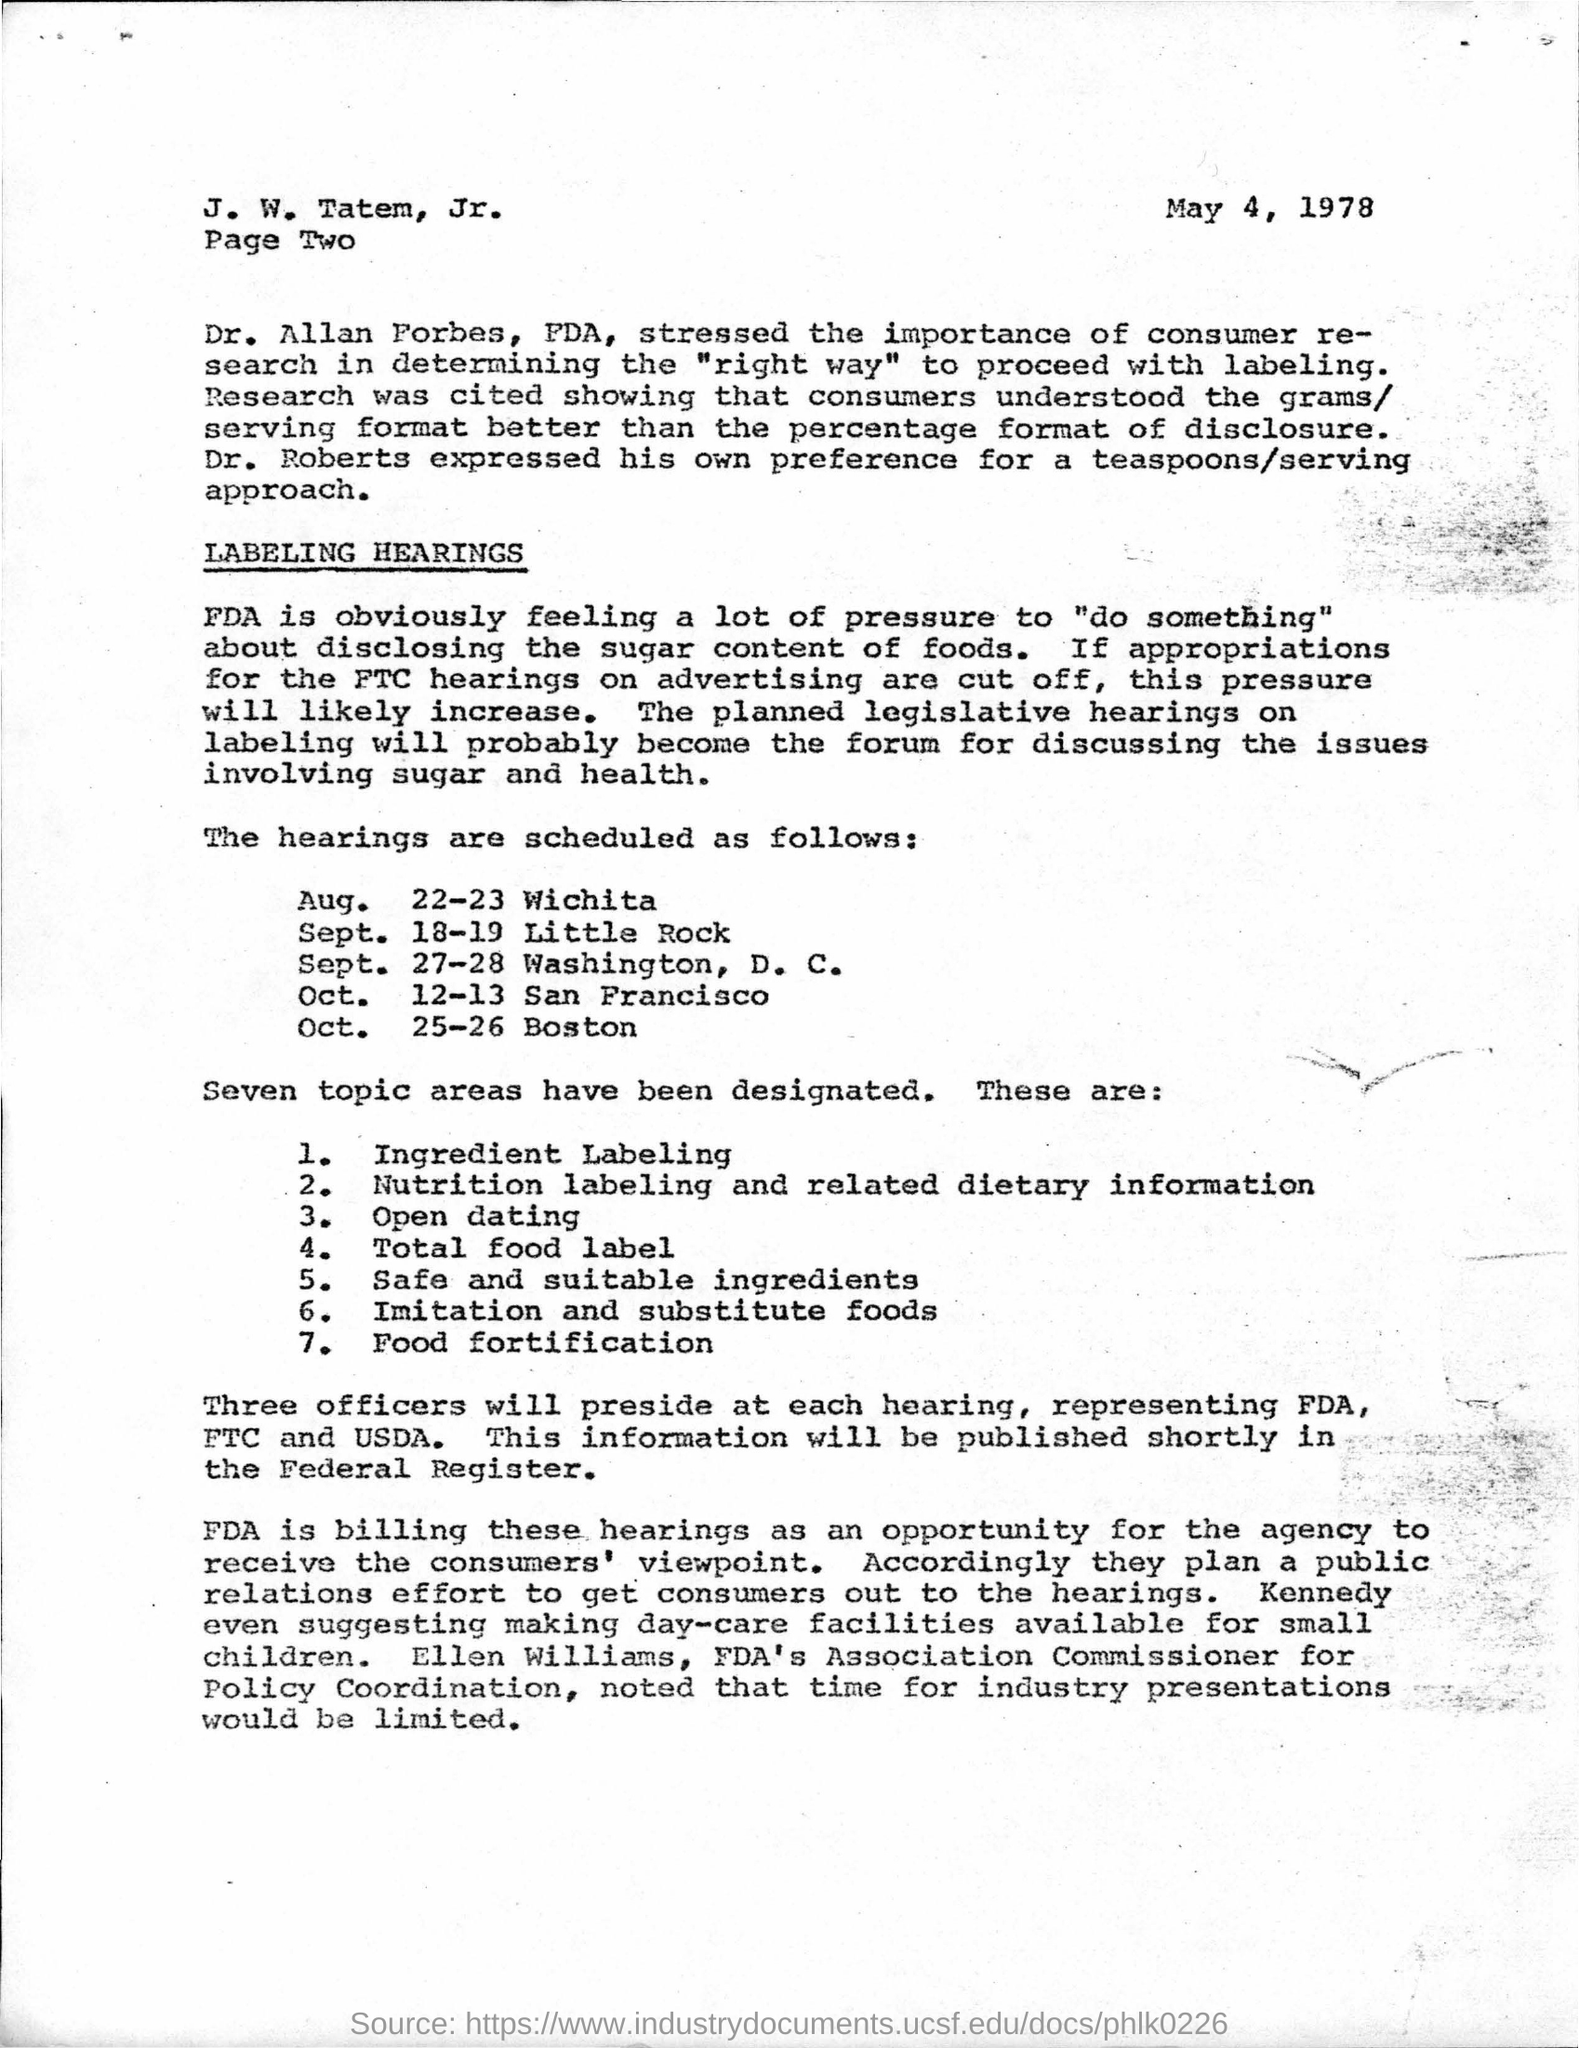When is the hearing scheduled for San Francisco?
Your response must be concise. OCT. 12-13. When is the hearing scheduled for Wichita?
Provide a short and direct response. Aug. 22-23. 